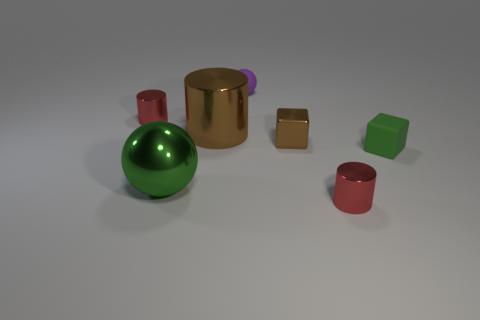What number of objects are both behind the large green metallic object and to the right of the tiny purple matte object?
Offer a very short reply. 2. The big brown thing that is made of the same material as the large ball is what shape?
Your answer should be compact. Cylinder. Is the size of the cylinder that is right of the big brown shiny object the same as the rubber thing in front of the small purple rubber thing?
Offer a very short reply. Yes. The small metallic object to the left of the tiny purple rubber ball is what color?
Give a very brief answer. Red. There is a large thing that is to the left of the brown thing that is left of the small purple matte ball; what is its material?
Make the answer very short. Metal. What is the shape of the small brown metallic thing?
Provide a short and direct response. Cube. What is the material of the big green thing that is the same shape as the small purple matte object?
Provide a succinct answer. Metal. How many purple metal balls are the same size as the rubber ball?
Offer a very short reply. 0. There is a small purple rubber thing to the left of the tiny rubber cube; are there any tiny purple spheres that are left of it?
Give a very brief answer. No. How many yellow objects are either large matte blocks or metallic things?
Your answer should be compact. 0. 